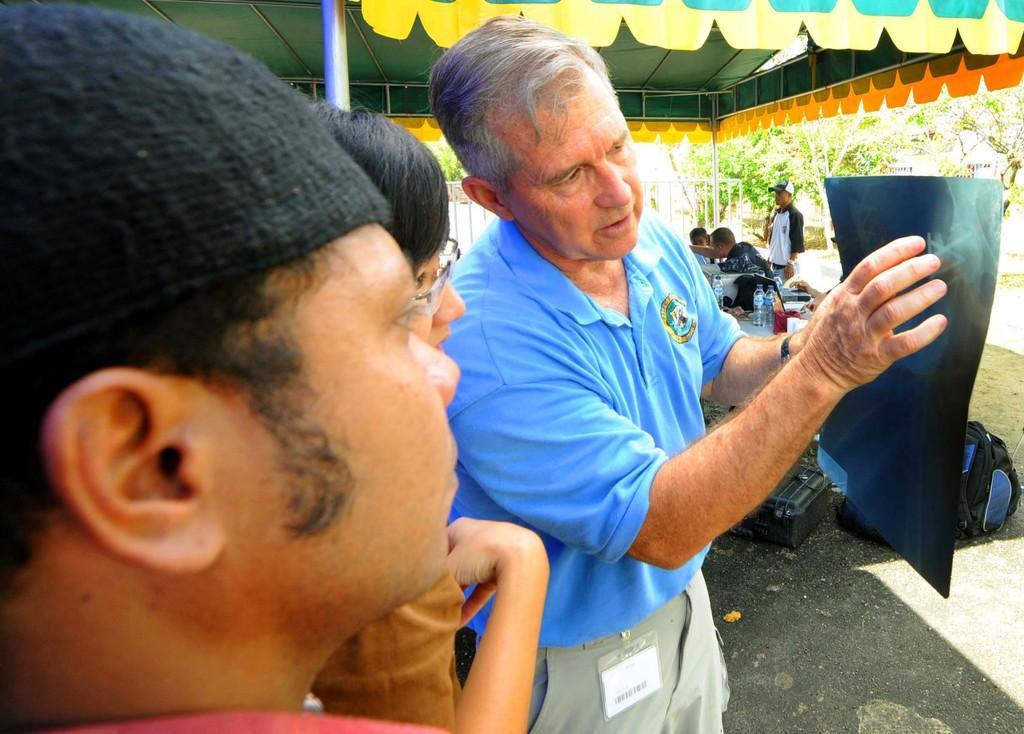In one or two sentences, can you explain what this image depicts? In this picture I can see group of people among them some are sitting and some are standing. The person in the front is holding an object in the hand. In the background i can see pole, trees and tables. On the tables i can see bottles and other objects on it. On the right side i can see bag, box and other objects on the ground. 